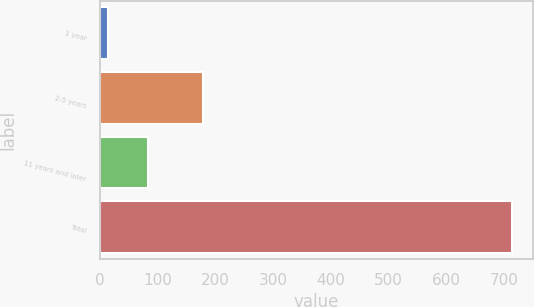<chart> <loc_0><loc_0><loc_500><loc_500><bar_chart><fcel>1 year<fcel>2-5 years<fcel>11 years and later<fcel>Total<nl><fcel>14<fcel>178<fcel>84<fcel>714<nl></chart> 